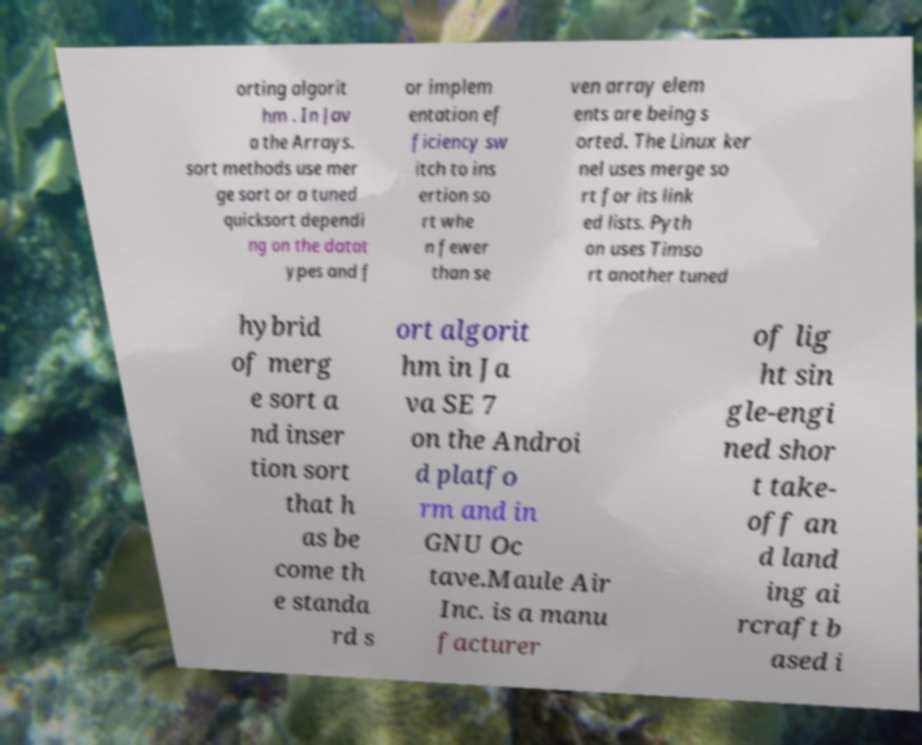Can you read and provide the text displayed in the image?This photo seems to have some interesting text. Can you extract and type it out for me? orting algorit hm . In Jav a the Arrays. sort methods use mer ge sort or a tuned quicksort dependi ng on the datat ypes and f or implem entation ef ficiency sw itch to ins ertion so rt whe n fewer than se ven array elem ents are being s orted. The Linux ker nel uses merge so rt for its link ed lists. Pyth on uses Timso rt another tuned hybrid of merg e sort a nd inser tion sort that h as be come th e standa rd s ort algorit hm in Ja va SE 7 on the Androi d platfo rm and in GNU Oc tave.Maule Air Inc. is a manu facturer of lig ht sin gle-engi ned shor t take- off an d land ing ai rcraft b ased i 